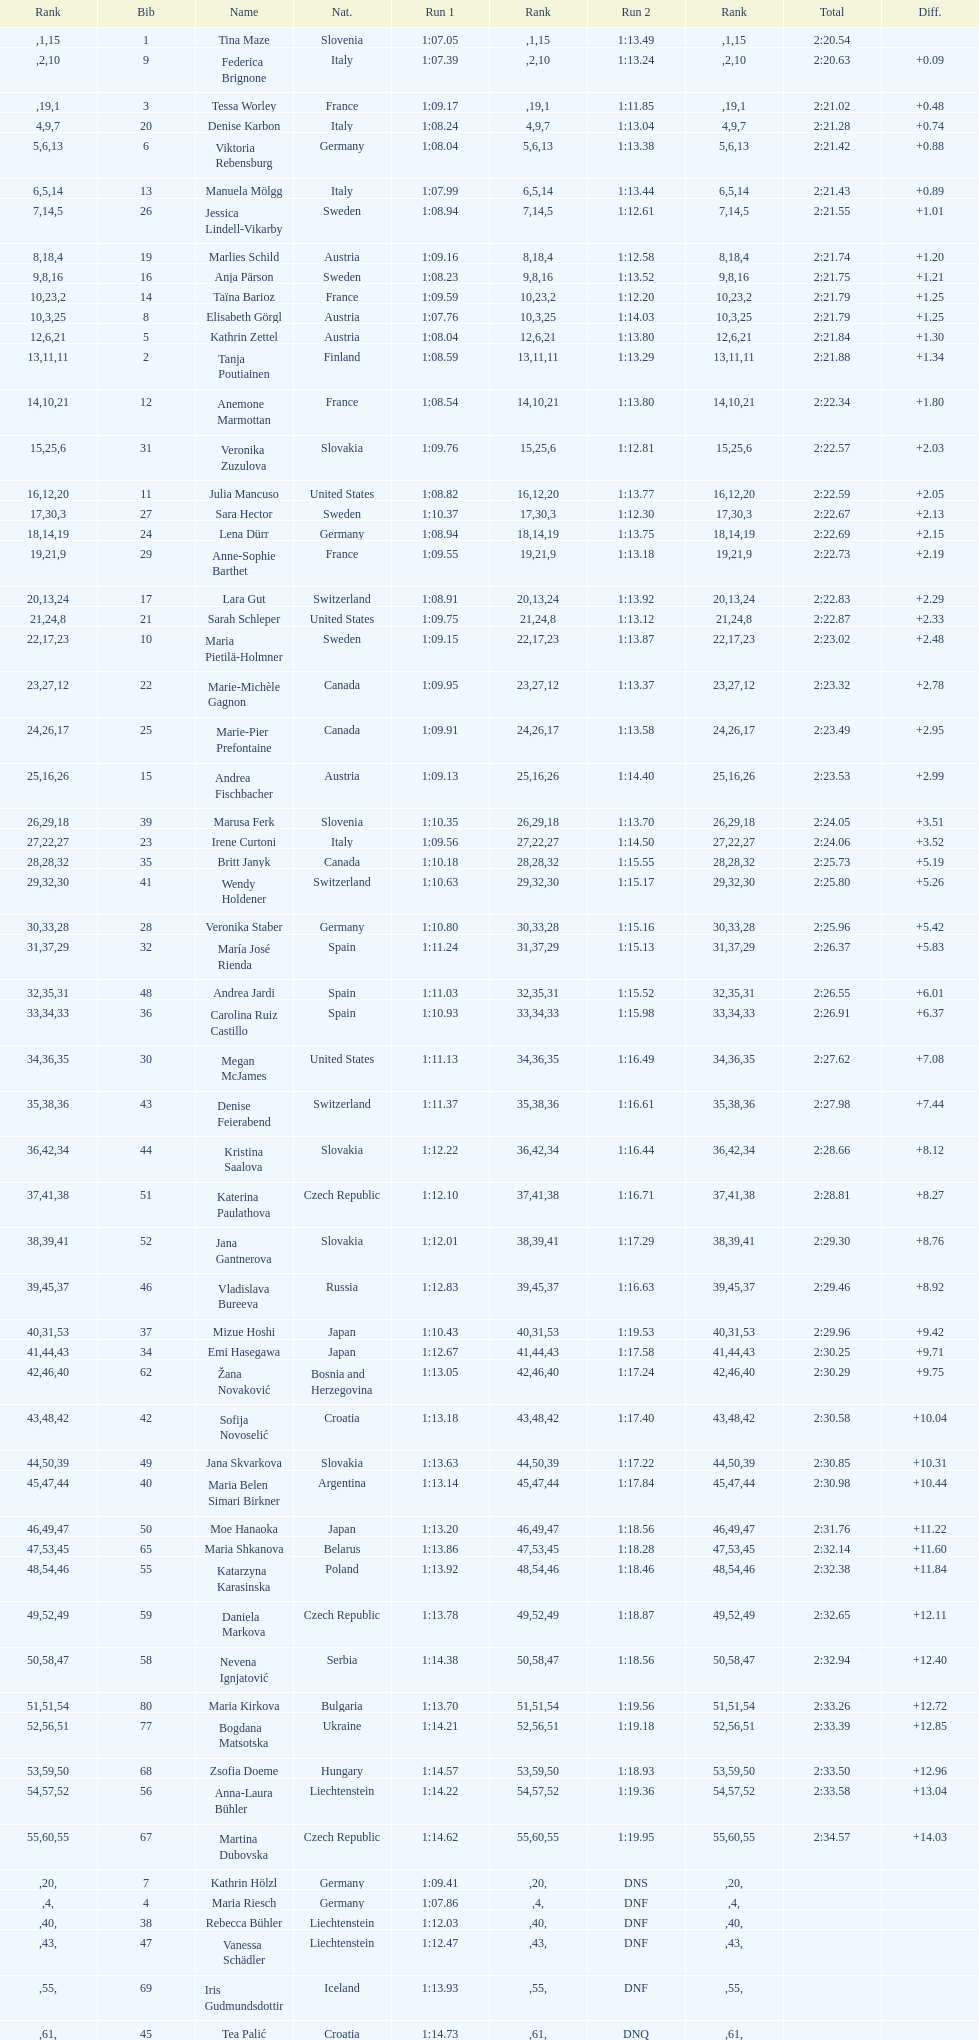Who finished next after federica brignone? Tessa Worley. 